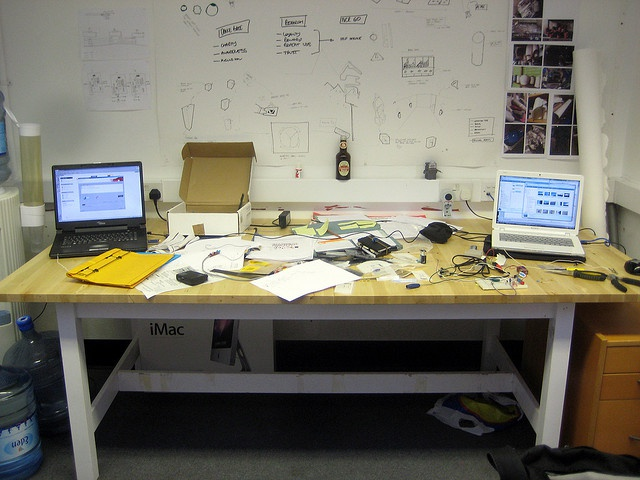Describe the objects in this image and their specific colors. I can see laptop in gray, black, lavender, and lightblue tones, laptop in gray, lightgray, lightblue, and darkgray tones, bottle in gray, black, tan, and darkgray tones, and mouse in gray, black, navy, and olive tones in this image. 